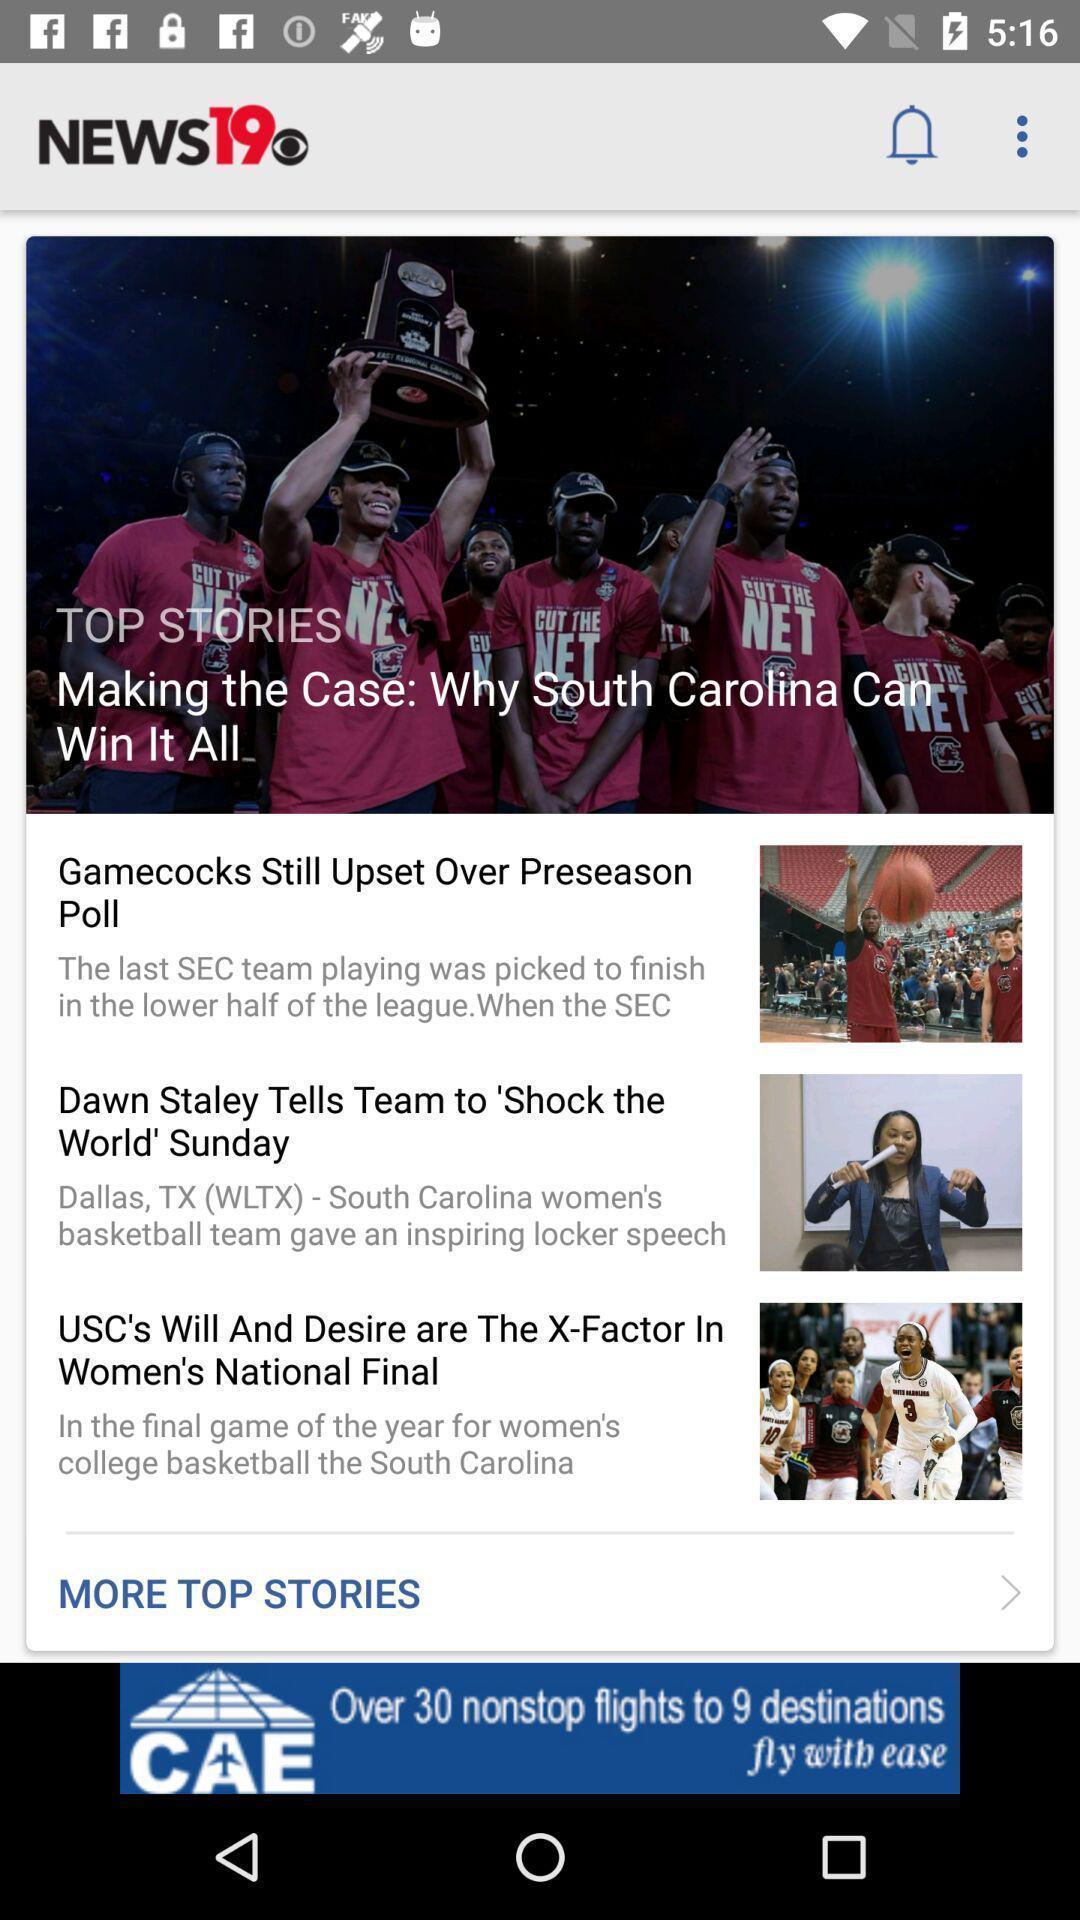Summarize the main components in this picture. Top stories in a news app. 